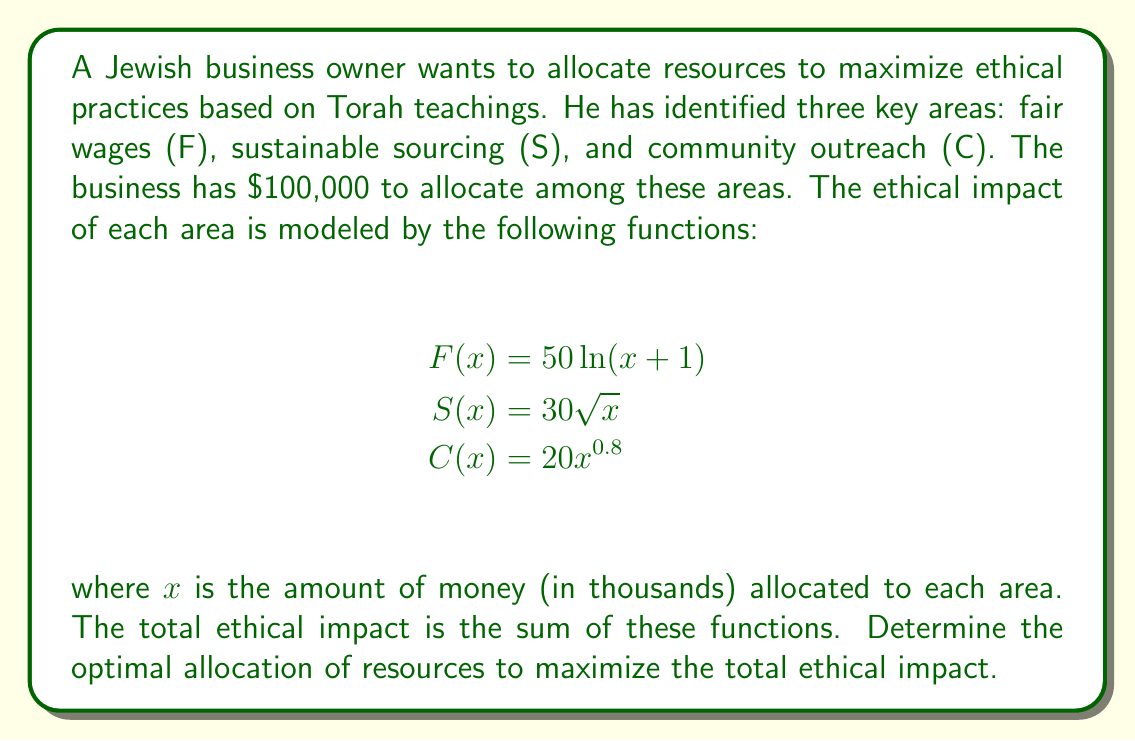Teach me how to tackle this problem. To solve this optimization problem, we'll use the method of Lagrange multipliers. Let's follow these steps:

1) Define the objective function:
   $$T(x, y, z) = 50\ln(x + 1) + 30\sqrt{y} + 20z^{0.8}$$

2) Define the constraint:
   $$x + y + z = 100$$

3) Form the Lagrangian:
   $$L(x, y, z, \lambda) = 50\ln(x + 1) + 30\sqrt{y} + 20z^{0.8} - \lambda(x + y + z - 100)$$

4) Take partial derivatives and set them equal to zero:
   $$\frac{\partial L}{\partial x} = \frac{50}{x + 1} - \lambda = 0$$
   $$\frac{\partial L}{\partial y} = \frac{15}{\sqrt{y}} - \lambda = 0$$
   $$\frac{\partial L}{\partial z} = \frac{16}{z^{0.2}} - \lambda = 0$$
   $$\frac{\partial L}{\partial \lambda} = x + y + z - 100 = 0$$

5) From these equations, we can derive:
   $$x + 1 = \frac{50}{\lambda}$$
   $$y = (\frac{15}{\lambda})^2$$
   $$z = (\frac{16}{\lambda})^{5}$$

6) Substitute these into the constraint equation:
   $$\frac{50}{\lambda} - 1 + (\frac{15}{\lambda})^2 + (\frac{16}{\lambda})^{5} = 100$$

7) This equation can be solved numerically to find λ ≈ 0.6906

8) Substituting this value back into the equations from step 5:
   $$x ≈ 71.39$$
   $$y ≈ 21.70$$
   $$z ≈ 6.91$$

Therefore, the optimal allocation is approximately:
Fair wages: $71,390
Sustainable sourcing: $21,700
Community outreach: $6,910
Answer: The optimal allocation to maximize ethical impact is:
Fair wages: $71,390
Sustainable sourcing: $21,700
Community outreach: $6,910 